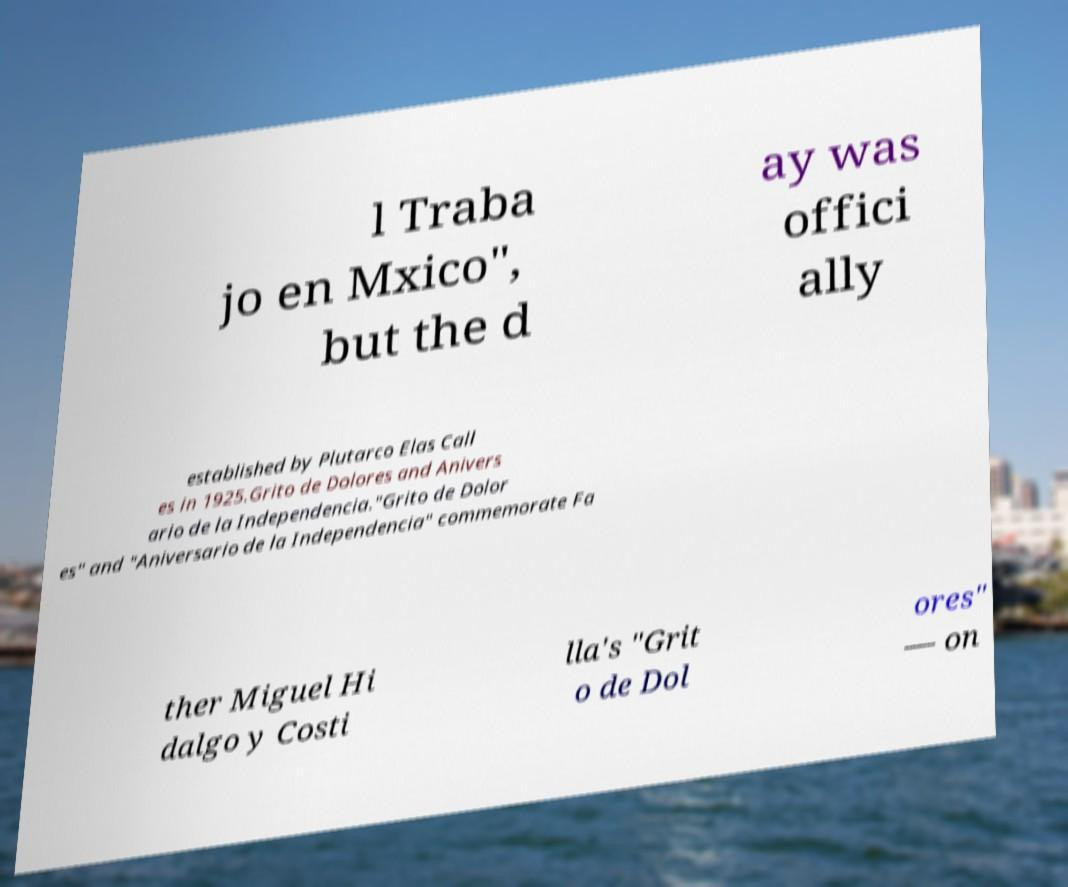For documentation purposes, I need the text within this image transcribed. Could you provide that? l Traba jo en Mxico", but the d ay was offici ally established by Plutarco Elas Call es in 1925.Grito de Dolores and Anivers ario de la Independencia."Grito de Dolor es" and "Aniversario de la Independencia" commemorate Fa ther Miguel Hi dalgo y Costi lla's "Grit o de Dol ores" — on 